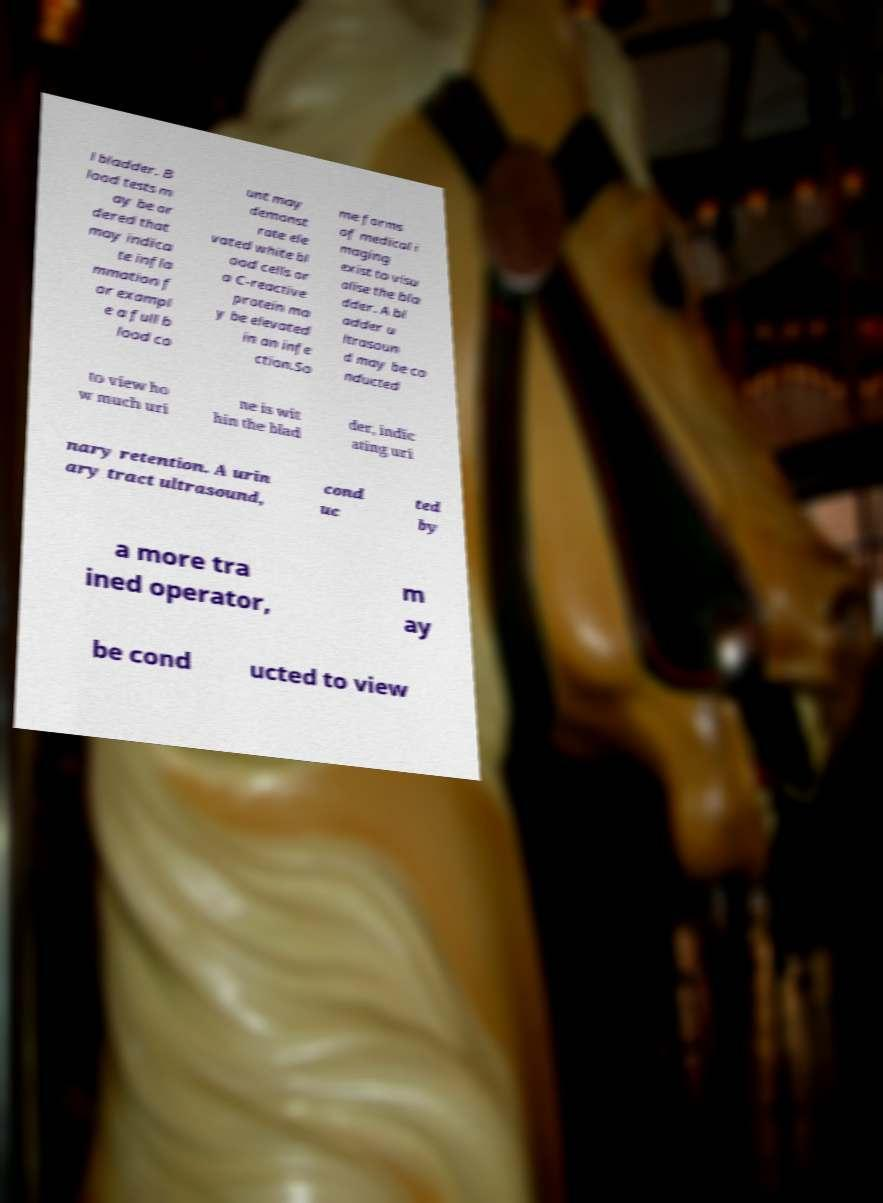Can you accurately transcribe the text from the provided image for me? l bladder. B lood tests m ay be or dered that may indica te infla mmation f or exampl e a full b lood co unt may demonst rate ele vated white bl ood cells or a C-reactive protein ma y be elevated in an infe ction.So me forms of medical i maging exist to visu alise the bla dder. A bl adder u ltrasoun d may be co nducted to view ho w much uri ne is wit hin the blad der, indic ating uri nary retention. A urin ary tract ultrasound, cond uc ted by a more tra ined operator, m ay be cond ucted to view 